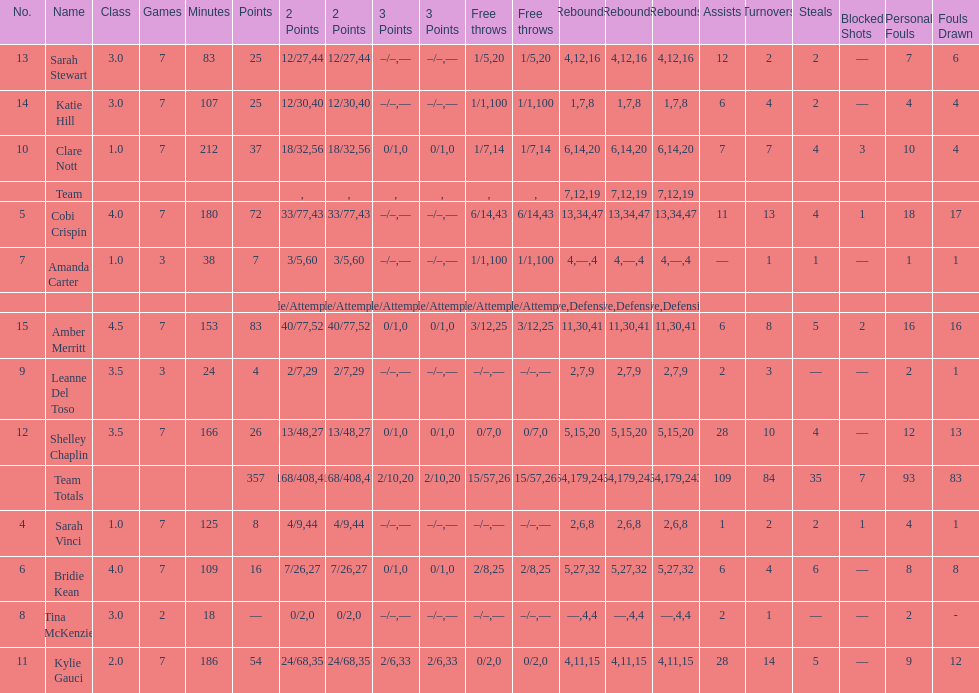Next to merritt, who was the top scorer? Cobi Crispin. 